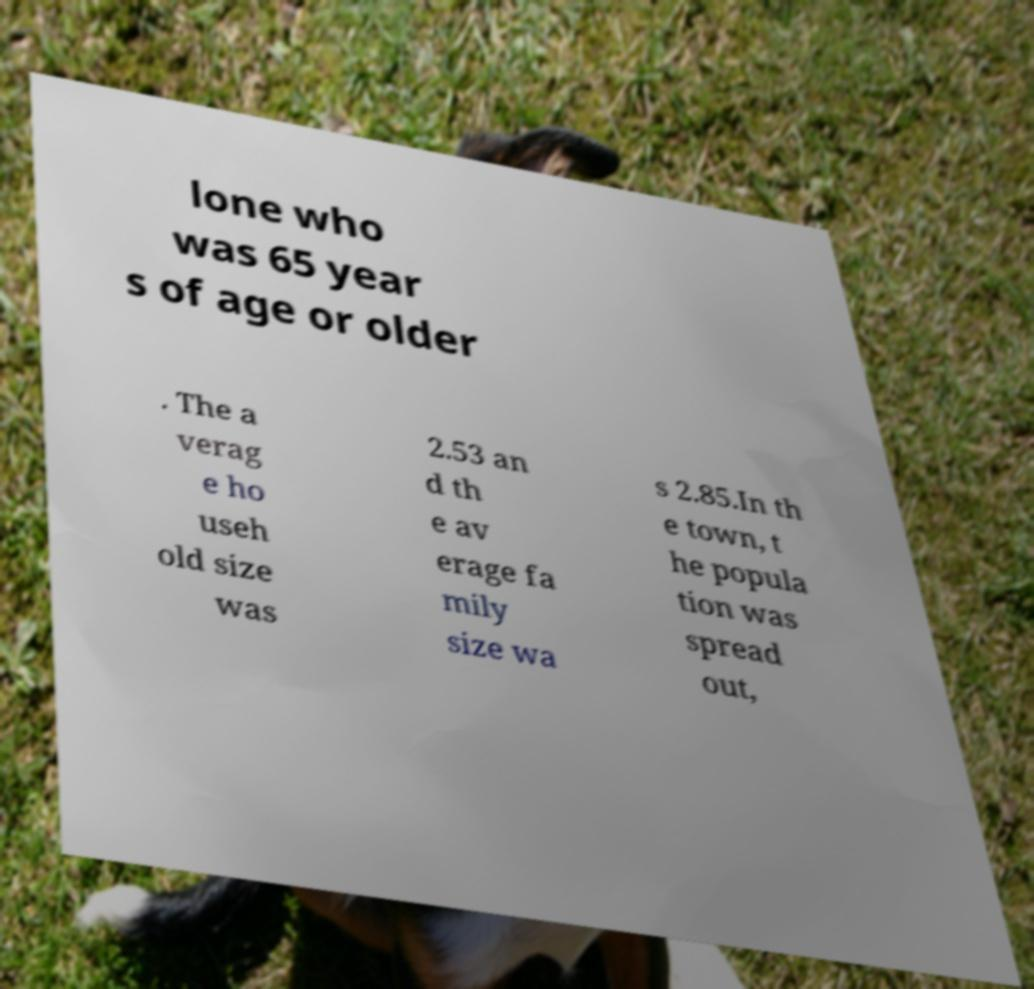What messages or text are displayed in this image? I need them in a readable, typed format. lone who was 65 year s of age or older . The a verag e ho useh old size was 2.53 an d th e av erage fa mily size wa s 2.85.In th e town, t he popula tion was spread out, 